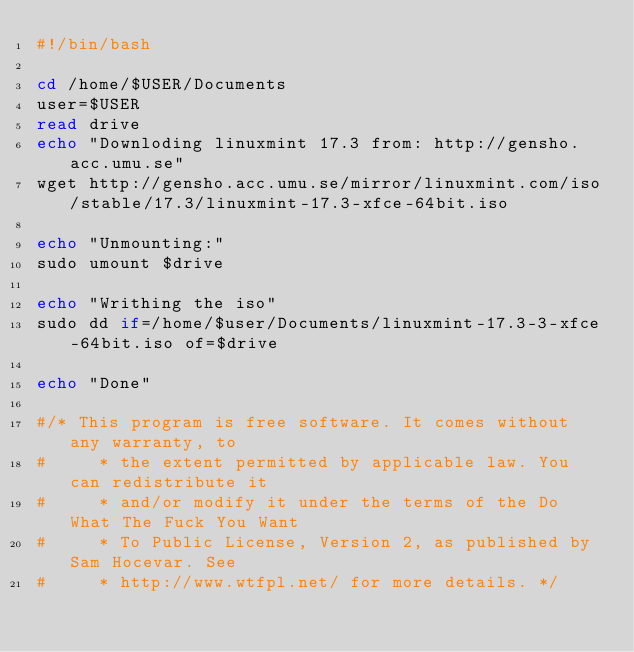Convert code to text. <code><loc_0><loc_0><loc_500><loc_500><_Bash_>#!/bin/bash

cd /home/$USER/Documents
user=$USER
read drive
echo "Downloding linuxmint 17.3 from: http://gensho.acc.umu.se"
wget http://gensho.acc.umu.se/mirror/linuxmint.com/iso/stable/17.3/linuxmint-17.3-xfce-64bit.iso

echo "Unmounting:"
sudo umount $drive

echo "Writhing the iso"
sudo dd if=/home/$user/Documents/linuxmint-17.3-3-xfce-64bit.iso of=$drive

echo "Done"

#/* This program is free software. It comes without any warranty, to
#     * the extent permitted by applicable law. You can redistribute it
#     * and/or modify it under the terms of the Do What The Fuck You Want
#     * To Public License, Version 2, as published by Sam Hocevar. See
#     * http://www.wtfpl.net/ for more details. */
</code> 